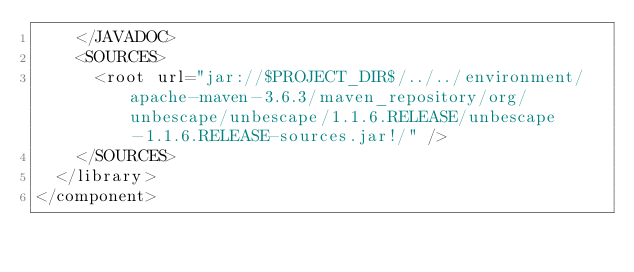<code> <loc_0><loc_0><loc_500><loc_500><_XML_>    </JAVADOC>
    <SOURCES>
      <root url="jar://$PROJECT_DIR$/../../environment/apache-maven-3.6.3/maven_repository/org/unbescape/unbescape/1.1.6.RELEASE/unbescape-1.1.6.RELEASE-sources.jar!/" />
    </SOURCES>
  </library>
</component></code> 